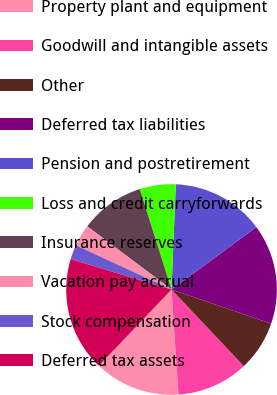<chart> <loc_0><loc_0><loc_500><loc_500><pie_chart><fcel>Property plant and equipment<fcel>Goodwill and intangible assets<fcel>Other<fcel>Deferred tax liabilities<fcel>Pension and postretirement<fcel>Loss and credit carryforwards<fcel>Insurance reserves<fcel>Vacation pay accrual<fcel>Stock compensation<fcel>Deferred tax assets<nl><fcel>13.17%<fcel>10.98%<fcel>7.71%<fcel>15.35%<fcel>14.26%<fcel>5.52%<fcel>9.89%<fcel>3.34%<fcel>2.24%<fcel>17.54%<nl></chart> 